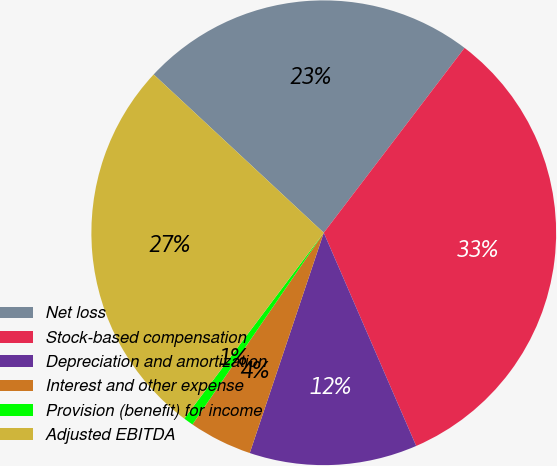<chart> <loc_0><loc_0><loc_500><loc_500><pie_chart><fcel>Net loss<fcel>Stock-based compensation<fcel>Depreciation and amortization<fcel>Interest and other expense<fcel>Provision (benefit) for income<fcel>Adjusted EBITDA<nl><fcel>23.43%<fcel>33.13%<fcel>11.67%<fcel>4.4%<fcel>0.69%<fcel>26.68%<nl></chart> 